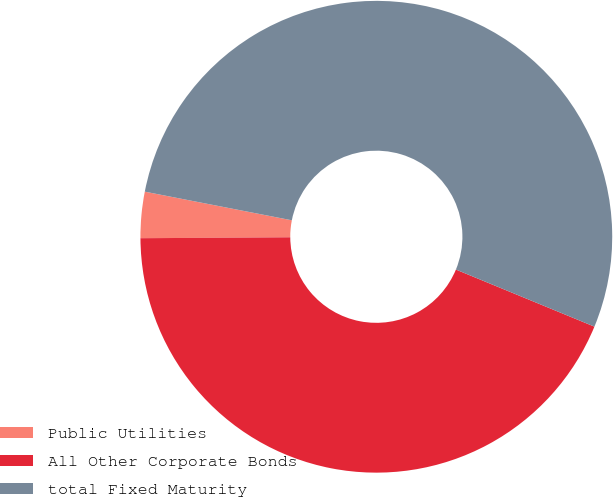Convert chart to OTSL. <chart><loc_0><loc_0><loc_500><loc_500><pie_chart><fcel>Public Utilities<fcel>All Other Corporate Bonds<fcel>total Fixed Maturity<nl><fcel>3.16%<fcel>43.68%<fcel>53.16%<nl></chart> 